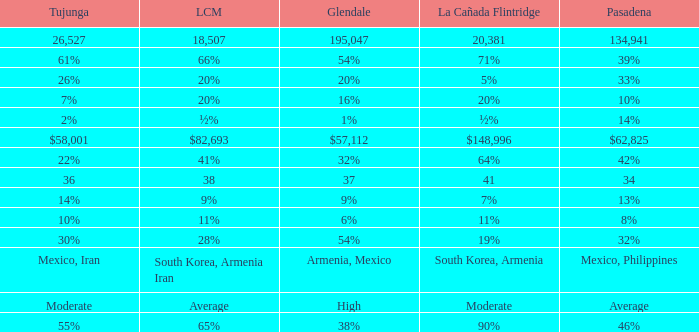What is the percentage of Tujunja when Pasadena is 33%? 26%. 